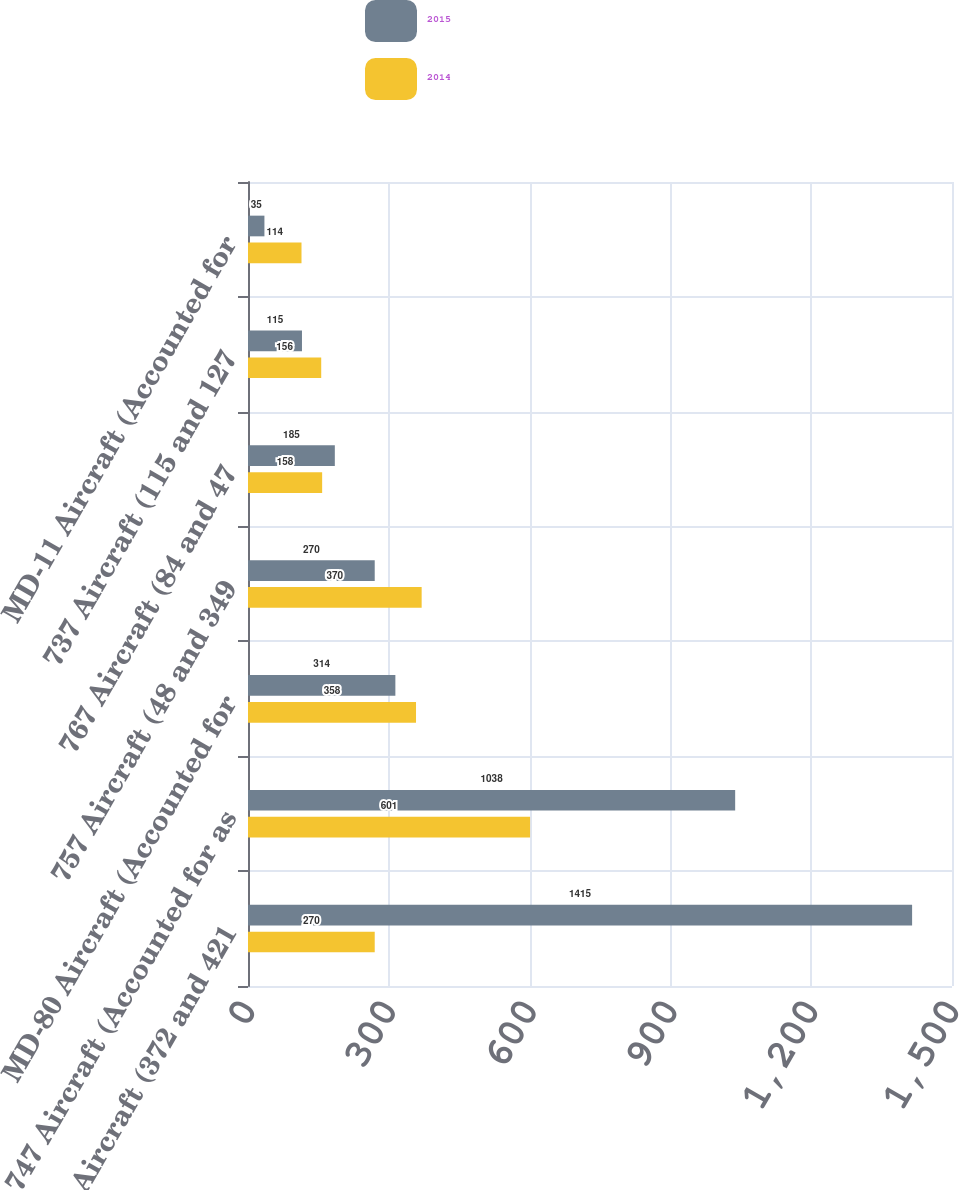Convert chart. <chart><loc_0><loc_0><loc_500><loc_500><stacked_bar_chart><ecel><fcel>717 Aircraft (372 and 421<fcel>747 Aircraft (Accounted for as<fcel>MD-80 Aircraft (Accounted for<fcel>757 Aircraft (48 and 349<fcel>767 Aircraft (84 and 47<fcel>737 Aircraft (115 and 127<fcel>MD-11 Aircraft (Accounted for<nl><fcel>2015<fcel>1415<fcel>1038<fcel>314<fcel>270<fcel>185<fcel>115<fcel>35<nl><fcel>2014<fcel>270<fcel>601<fcel>358<fcel>370<fcel>158<fcel>156<fcel>114<nl></chart> 